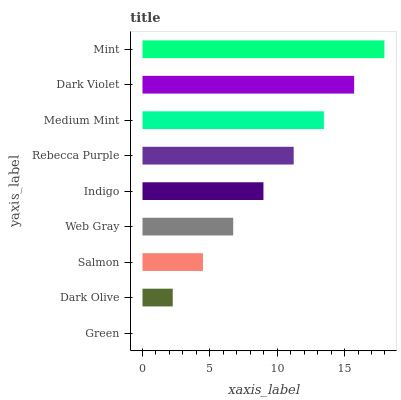Is Green the minimum?
Answer yes or no. Yes. Is Mint the maximum?
Answer yes or no. Yes. Is Dark Olive the minimum?
Answer yes or no. No. Is Dark Olive the maximum?
Answer yes or no. No. Is Dark Olive greater than Green?
Answer yes or no. Yes. Is Green less than Dark Olive?
Answer yes or no. Yes. Is Green greater than Dark Olive?
Answer yes or no. No. Is Dark Olive less than Green?
Answer yes or no. No. Is Indigo the high median?
Answer yes or no. Yes. Is Indigo the low median?
Answer yes or no. Yes. Is Mint the high median?
Answer yes or no. No. Is Salmon the low median?
Answer yes or no. No. 